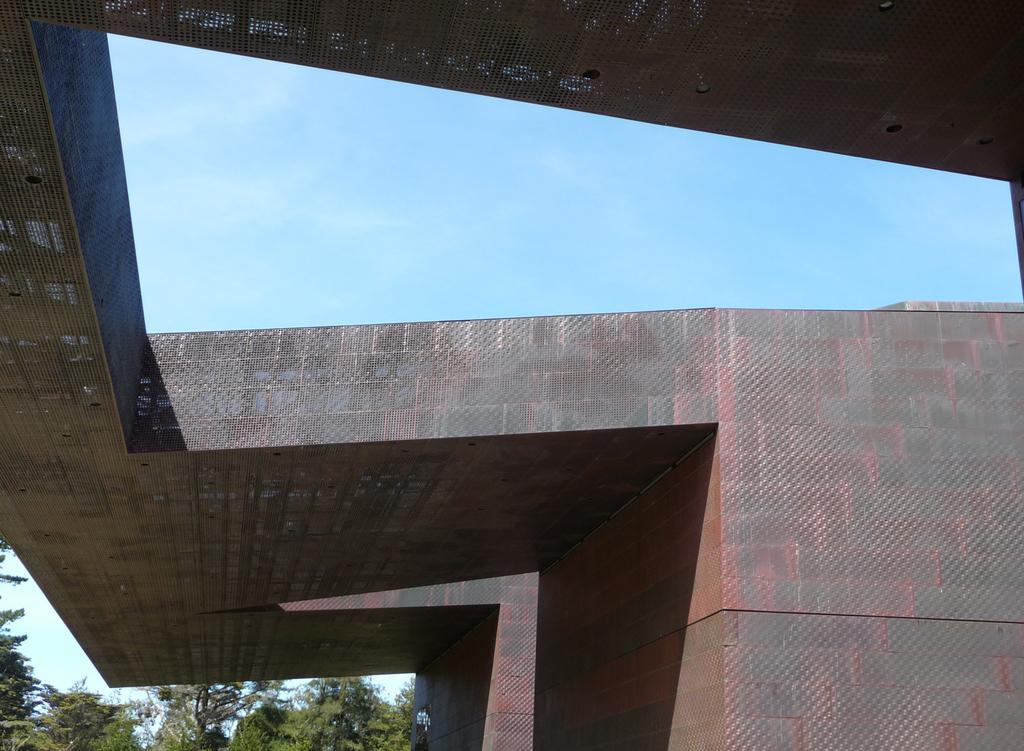What is the main subject in the center of the image? There is a building in the center of the image. What can be seen on the left side of the image? There are trees on the left side of the image. What is visible in the background of the image? The sky is visible in the background of the image. What type of company is located on the hill in the image? There is no hill or company present in the image. 